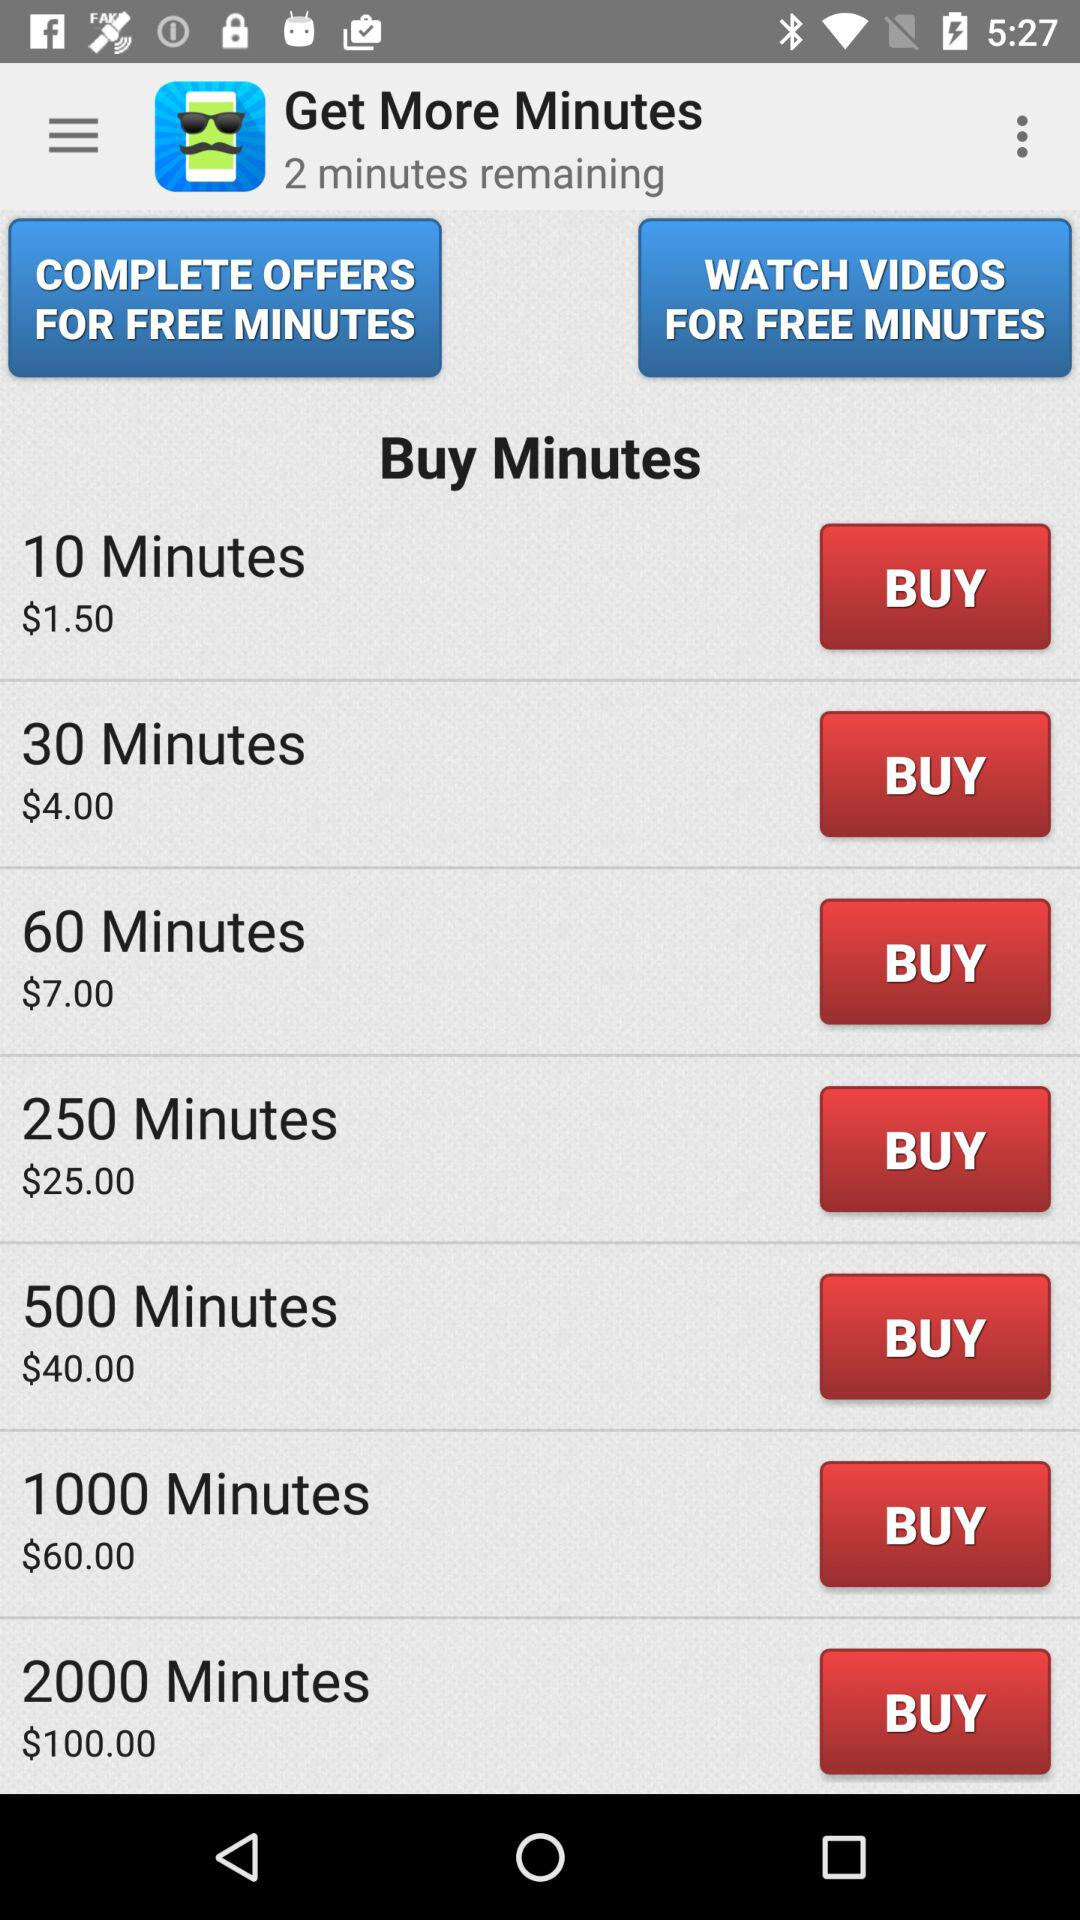What is the price of 10 minutes? The price of 10 minutes is $1.50. 